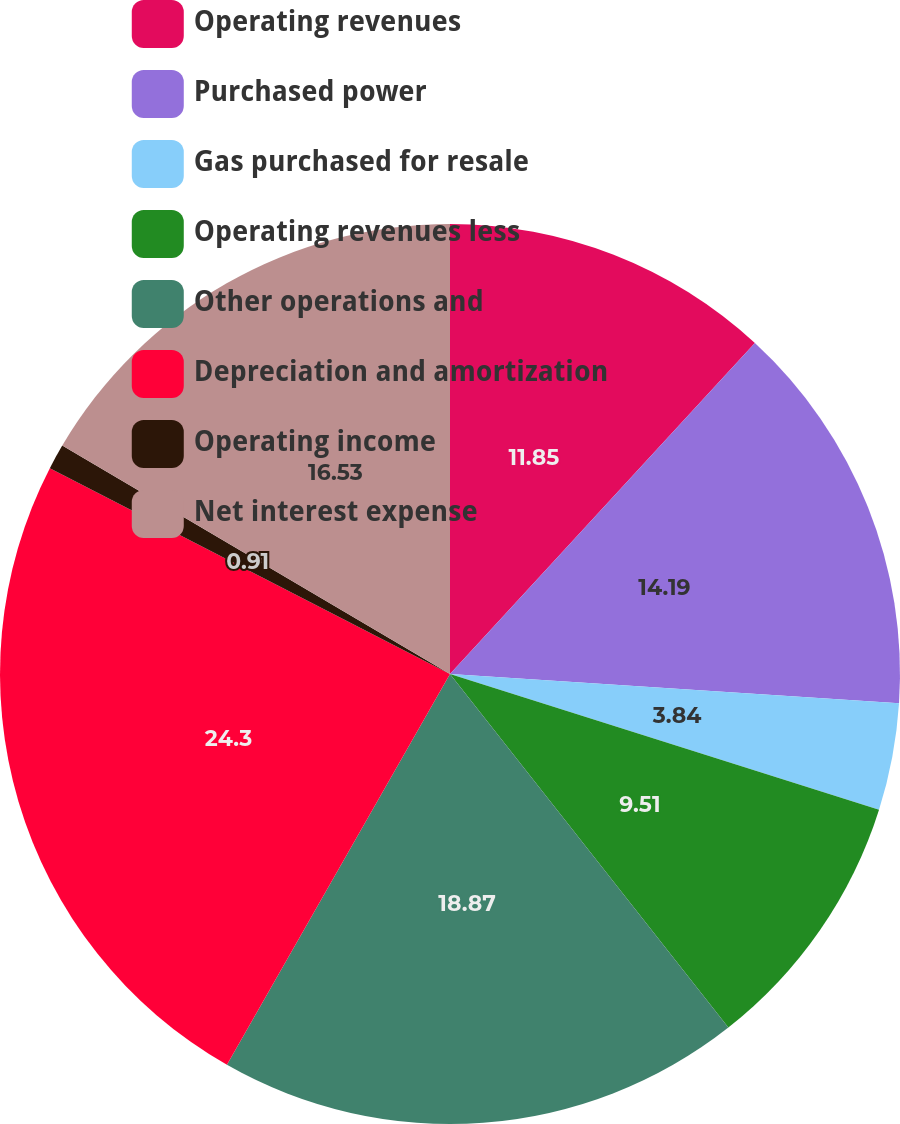<chart> <loc_0><loc_0><loc_500><loc_500><pie_chart><fcel>Operating revenues<fcel>Purchased power<fcel>Gas purchased for resale<fcel>Operating revenues less<fcel>Other operations and<fcel>Depreciation and amortization<fcel>Operating income<fcel>Net interest expense<nl><fcel>11.85%<fcel>14.19%<fcel>3.84%<fcel>9.51%<fcel>18.87%<fcel>24.31%<fcel>0.91%<fcel>16.53%<nl></chart> 